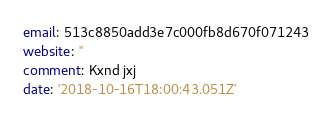<code> <loc_0><loc_0><loc_500><loc_500><_YAML_>email: 513c8850add3e7c000fb8d670f071243
website: ''
comment: Kxnd jxj
date: '2018-10-16T18:00:43.051Z'
</code> 